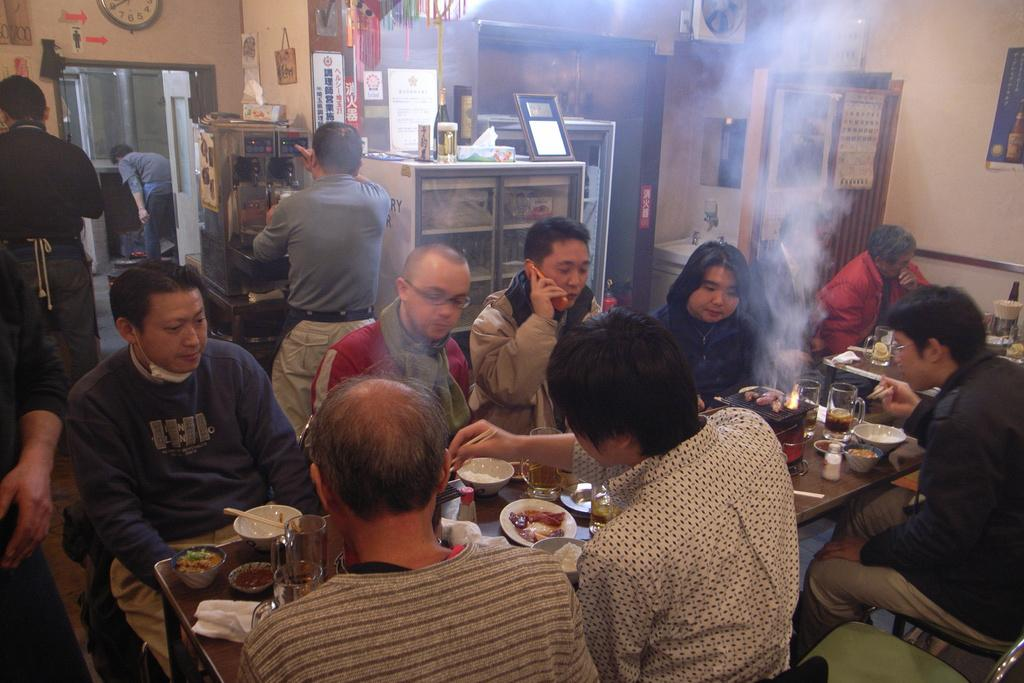What is happening in the image? There are people sitting in front of a table and people standing at the back side. What can be seen on the table? There are objects placed on the table. What is happening with the people standing at the back side? There are objects placed around the people standing at the back side. How many kittens are sitting on the table in the image? There are no kittens present in the image. What type of frogs can be seen hopping around the people standing at the back side? There are no frogs present in the image. 